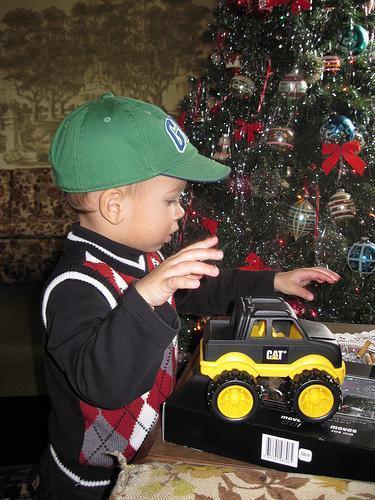How many people are pictured?
Give a very brief answer. 1. 